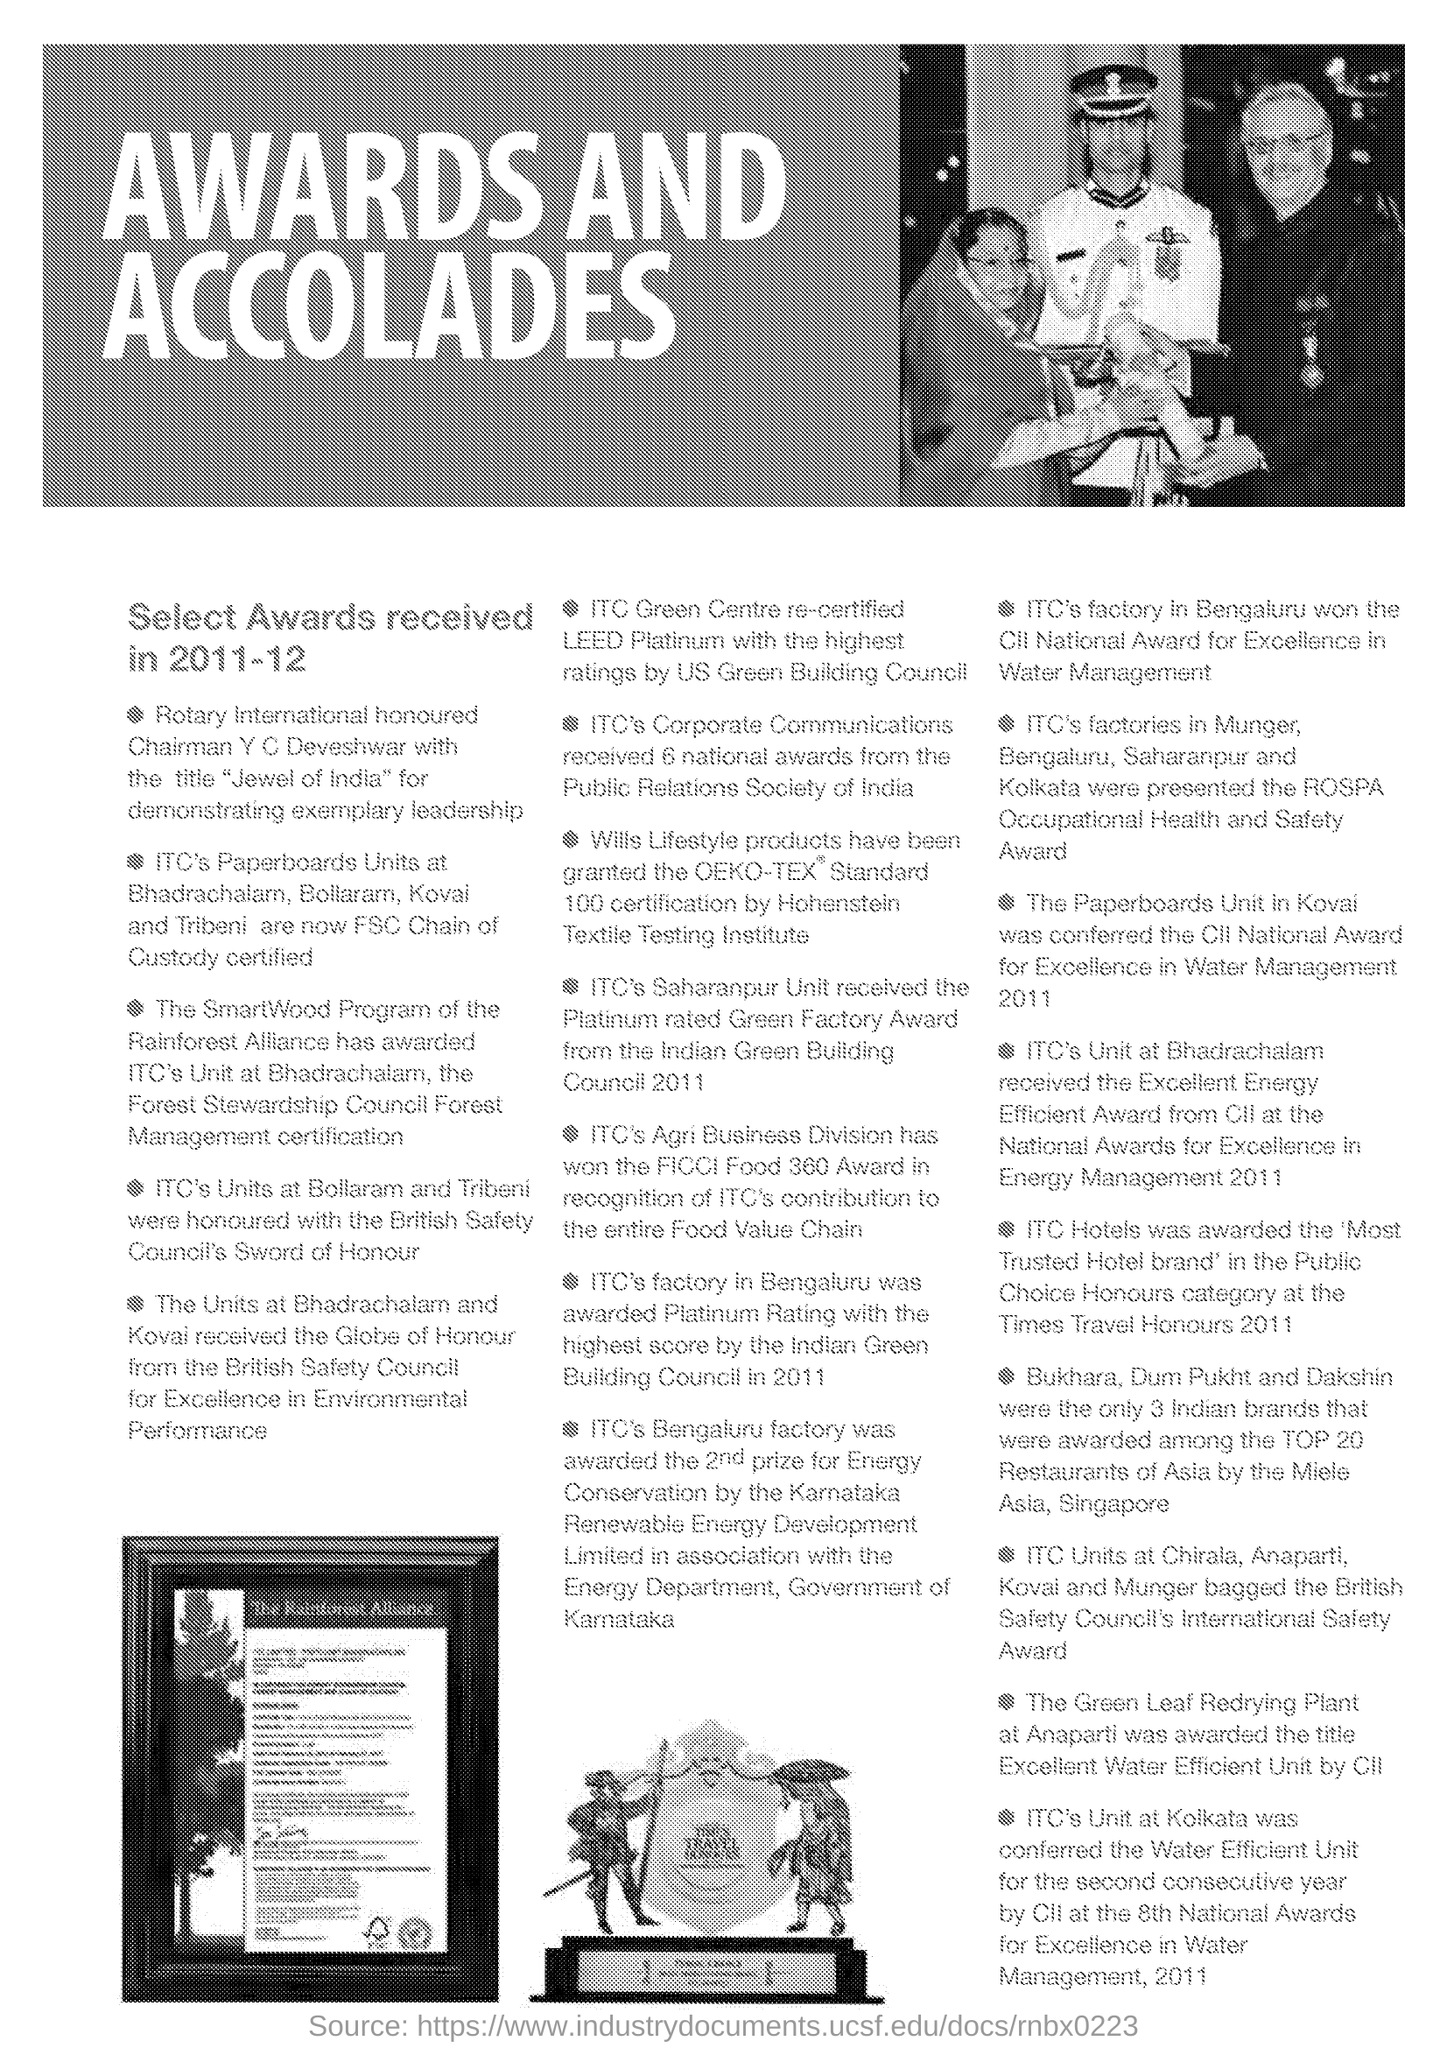Who was given the title "Jewel of India" for demonstrating exemplary leadership ?
Give a very brief answer. Chairman Y C Deveshwar. What is written in the Letter Head ?
Provide a succinct answer. AWARDS AND ACCOLADES. 